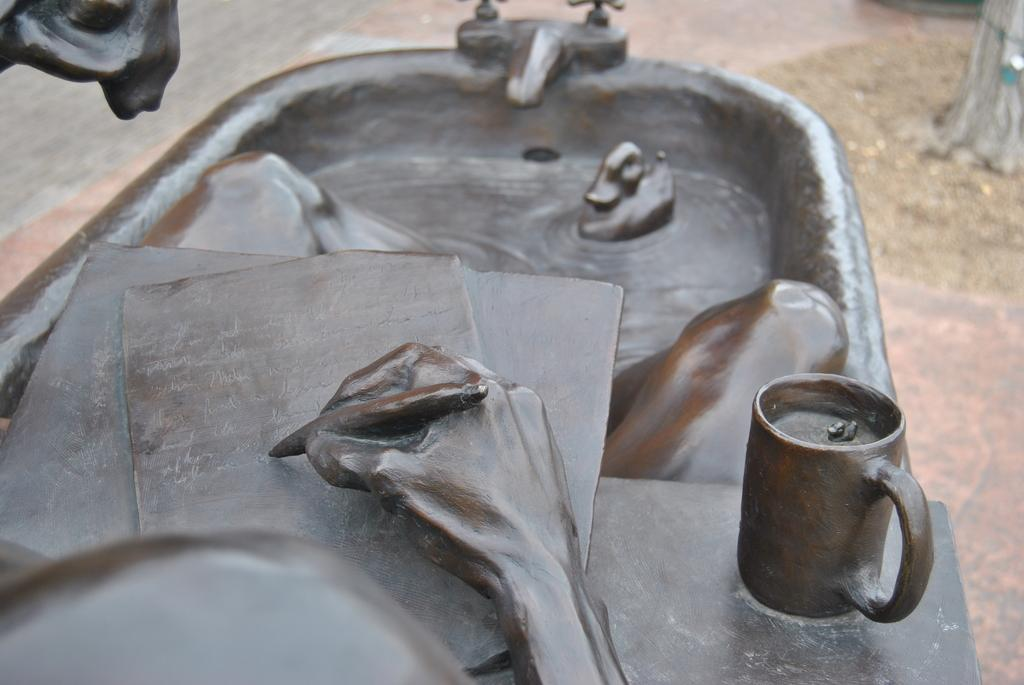What is the main object in the image? There is a statue in the image. What else can be seen in the image besides the statue? There is a cup, a human hand holding a pen, a bathtub, a duck, and taps visible in the image. What is the surface in the background of the image? The background of the image includes a surface, but the specific type of surface is not mentioned. What is the duck doing in the image? The duck is present in the image, but its actions are not described. How many grapes are on the duck's back in the image? There are no grapes present in the image, and the duck is not described as having any grapes on its back. 